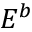Convert formula to latex. <formula><loc_0><loc_0><loc_500><loc_500>E ^ { b }</formula> 